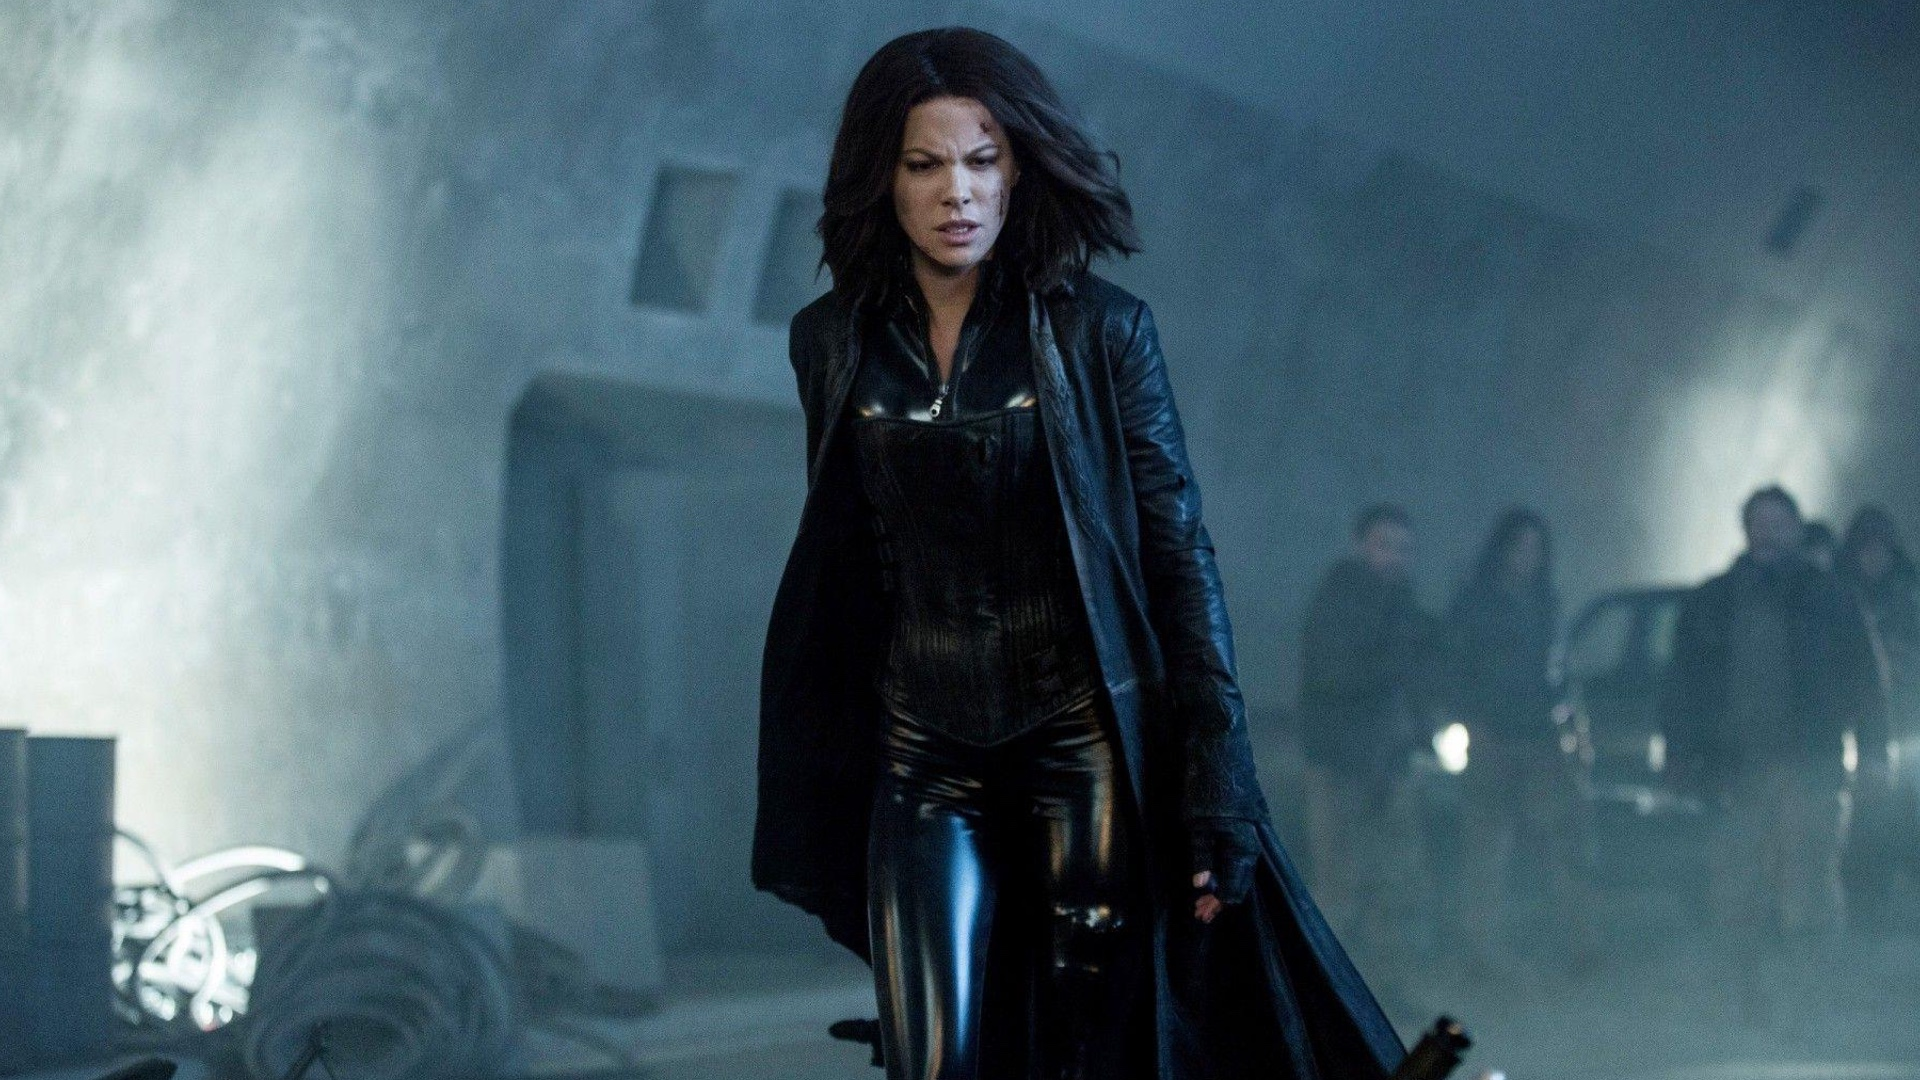What mood does this image convey? The image conveys a mood of intensity and suspense. The dark attire of the central figure, combined with the foggy, low-lit industrial setting, suggests a narrative filled with intrigue and perhaps danger. The determined stride and the direct gaze of the character add to the overall feeling of a serious and dramatic situation. 